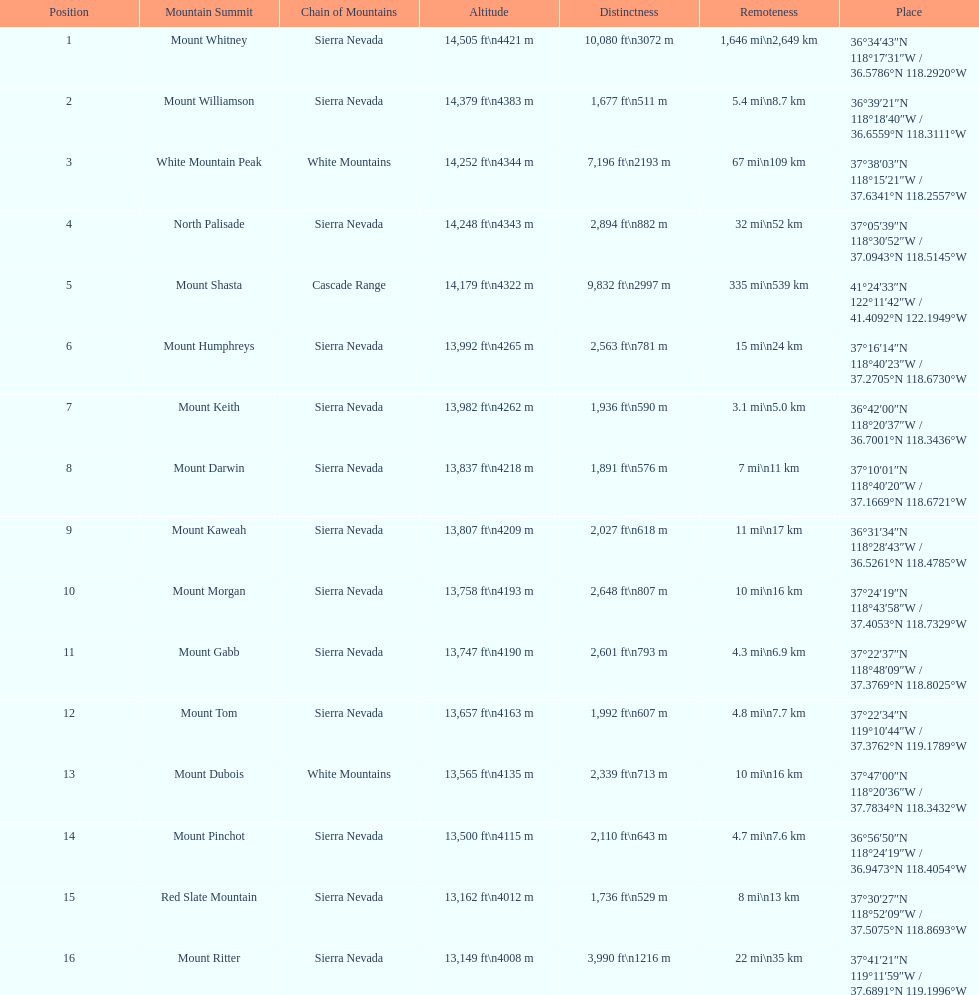Write the full table. {'header': ['Position', 'Mountain Summit', 'Chain of Mountains', 'Altitude', 'Distinctness', 'Remoteness', 'Place'], 'rows': [['1', 'Mount Whitney', 'Sierra Nevada', '14,505\xa0ft\\n4421\xa0m', '10,080\xa0ft\\n3072\xa0m', '1,646\xa0mi\\n2,649\xa0km', '36°34′43″N 118°17′31″W\ufeff / \ufeff36.5786°N 118.2920°W'], ['2', 'Mount Williamson', 'Sierra Nevada', '14,379\xa0ft\\n4383\xa0m', '1,677\xa0ft\\n511\xa0m', '5.4\xa0mi\\n8.7\xa0km', '36°39′21″N 118°18′40″W\ufeff / \ufeff36.6559°N 118.3111°W'], ['3', 'White Mountain Peak', 'White Mountains', '14,252\xa0ft\\n4344\xa0m', '7,196\xa0ft\\n2193\xa0m', '67\xa0mi\\n109\xa0km', '37°38′03″N 118°15′21″W\ufeff / \ufeff37.6341°N 118.2557°W'], ['4', 'North Palisade', 'Sierra Nevada', '14,248\xa0ft\\n4343\xa0m', '2,894\xa0ft\\n882\xa0m', '32\xa0mi\\n52\xa0km', '37°05′39″N 118°30′52″W\ufeff / \ufeff37.0943°N 118.5145°W'], ['5', 'Mount Shasta', 'Cascade Range', '14,179\xa0ft\\n4322\xa0m', '9,832\xa0ft\\n2997\xa0m', '335\xa0mi\\n539\xa0km', '41°24′33″N 122°11′42″W\ufeff / \ufeff41.4092°N 122.1949°W'], ['6', 'Mount Humphreys', 'Sierra Nevada', '13,992\xa0ft\\n4265\xa0m', '2,563\xa0ft\\n781\xa0m', '15\xa0mi\\n24\xa0km', '37°16′14″N 118°40′23″W\ufeff / \ufeff37.2705°N 118.6730°W'], ['7', 'Mount Keith', 'Sierra Nevada', '13,982\xa0ft\\n4262\xa0m', '1,936\xa0ft\\n590\xa0m', '3.1\xa0mi\\n5.0\xa0km', '36°42′00″N 118°20′37″W\ufeff / \ufeff36.7001°N 118.3436°W'], ['8', 'Mount Darwin', 'Sierra Nevada', '13,837\xa0ft\\n4218\xa0m', '1,891\xa0ft\\n576\xa0m', '7\xa0mi\\n11\xa0km', '37°10′01″N 118°40′20″W\ufeff / \ufeff37.1669°N 118.6721°W'], ['9', 'Mount Kaweah', 'Sierra Nevada', '13,807\xa0ft\\n4209\xa0m', '2,027\xa0ft\\n618\xa0m', '11\xa0mi\\n17\xa0km', '36°31′34″N 118°28′43″W\ufeff / \ufeff36.5261°N 118.4785°W'], ['10', 'Mount Morgan', 'Sierra Nevada', '13,758\xa0ft\\n4193\xa0m', '2,648\xa0ft\\n807\xa0m', '10\xa0mi\\n16\xa0km', '37°24′19″N 118°43′58″W\ufeff / \ufeff37.4053°N 118.7329°W'], ['11', 'Mount Gabb', 'Sierra Nevada', '13,747\xa0ft\\n4190\xa0m', '2,601\xa0ft\\n793\xa0m', '4.3\xa0mi\\n6.9\xa0km', '37°22′37″N 118°48′09″W\ufeff / \ufeff37.3769°N 118.8025°W'], ['12', 'Mount Tom', 'Sierra Nevada', '13,657\xa0ft\\n4163\xa0m', '1,992\xa0ft\\n607\xa0m', '4.8\xa0mi\\n7.7\xa0km', '37°22′34″N 119°10′44″W\ufeff / \ufeff37.3762°N 119.1789°W'], ['13', 'Mount Dubois', 'White Mountains', '13,565\xa0ft\\n4135\xa0m', '2,339\xa0ft\\n713\xa0m', '10\xa0mi\\n16\xa0km', '37°47′00″N 118°20′36″W\ufeff / \ufeff37.7834°N 118.3432°W'], ['14', 'Mount Pinchot', 'Sierra Nevada', '13,500\xa0ft\\n4115\xa0m', '2,110\xa0ft\\n643\xa0m', '4.7\xa0mi\\n7.6\xa0km', '36°56′50″N 118°24′19″W\ufeff / \ufeff36.9473°N 118.4054°W'], ['15', 'Red Slate Mountain', 'Sierra Nevada', '13,162\xa0ft\\n4012\xa0m', '1,736\xa0ft\\n529\xa0m', '8\xa0mi\\n13\xa0km', '37°30′27″N 118°52′09″W\ufeff / \ufeff37.5075°N 118.8693°W'], ['16', 'Mount Ritter', 'Sierra Nevada', '13,149\xa0ft\\n4008\xa0m', '3,990\xa0ft\\n1216\xa0m', '22\xa0mi\\n35\xa0km', '37°41′21″N 119°11′59″W\ufeff / \ufeff37.6891°N 119.1996°W']]} Which mountain peak has the least isolation? Mount Keith. 